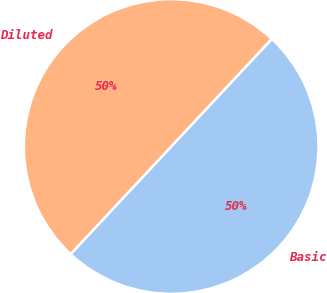Convert chart. <chart><loc_0><loc_0><loc_500><loc_500><pie_chart><fcel>Basic<fcel>Diluted<nl><fcel>50.0%<fcel>50.0%<nl></chart> 